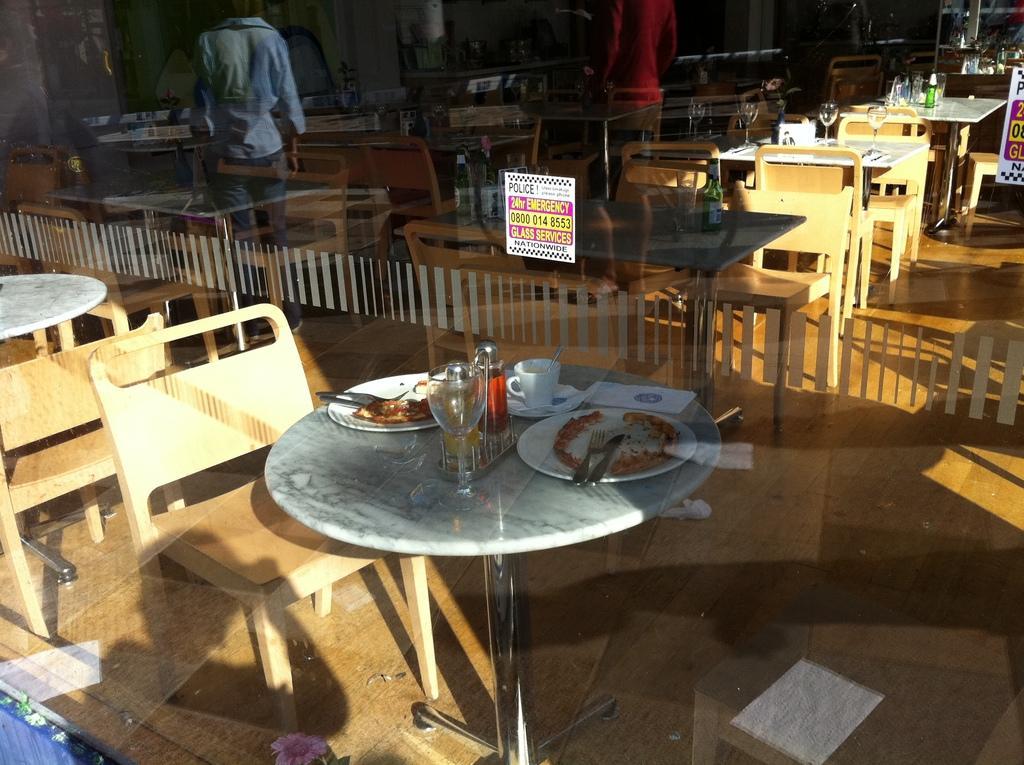Can you describe this image briefly? In this picture, there is a glass wall. Through the wall, we can see the tables and chairs. At the bottom, there is a table. On the table, there are plates, bottles, cups, forks, knives etc. On the glass, there is a paper with some text. At the top, there is a reflection of the person. 